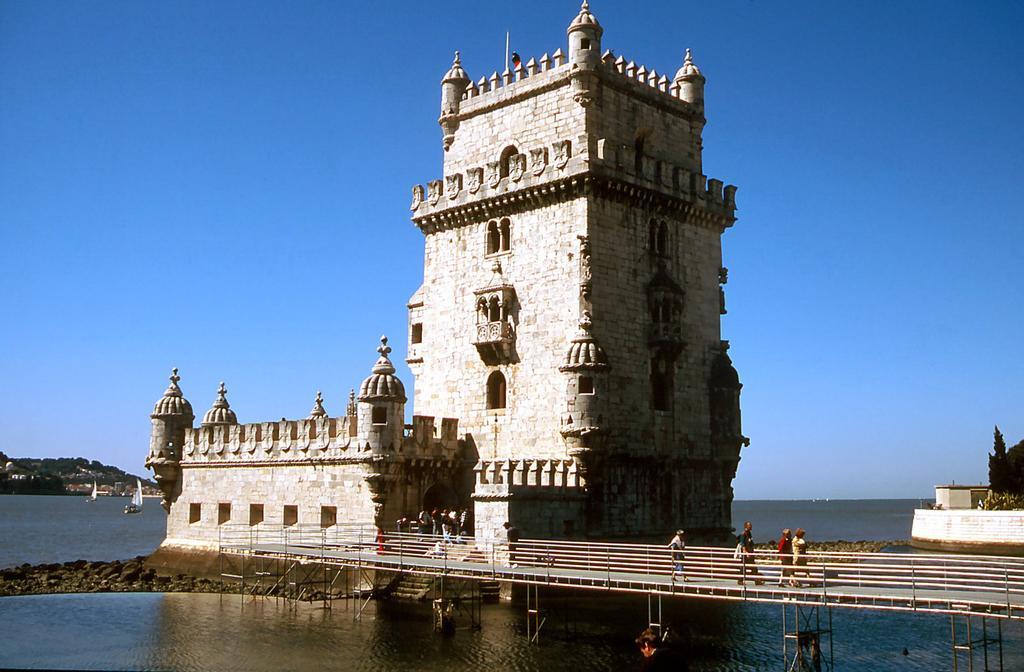Can you describe this image briefly? At the bottom we can see water and stones and we can see people are walking on the bridge. In the background we can see buildings,few persons,trees,boats on the water,mountain,houses and sky. 